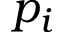Convert formula to latex. <formula><loc_0><loc_0><loc_500><loc_500>p _ { i }</formula> 